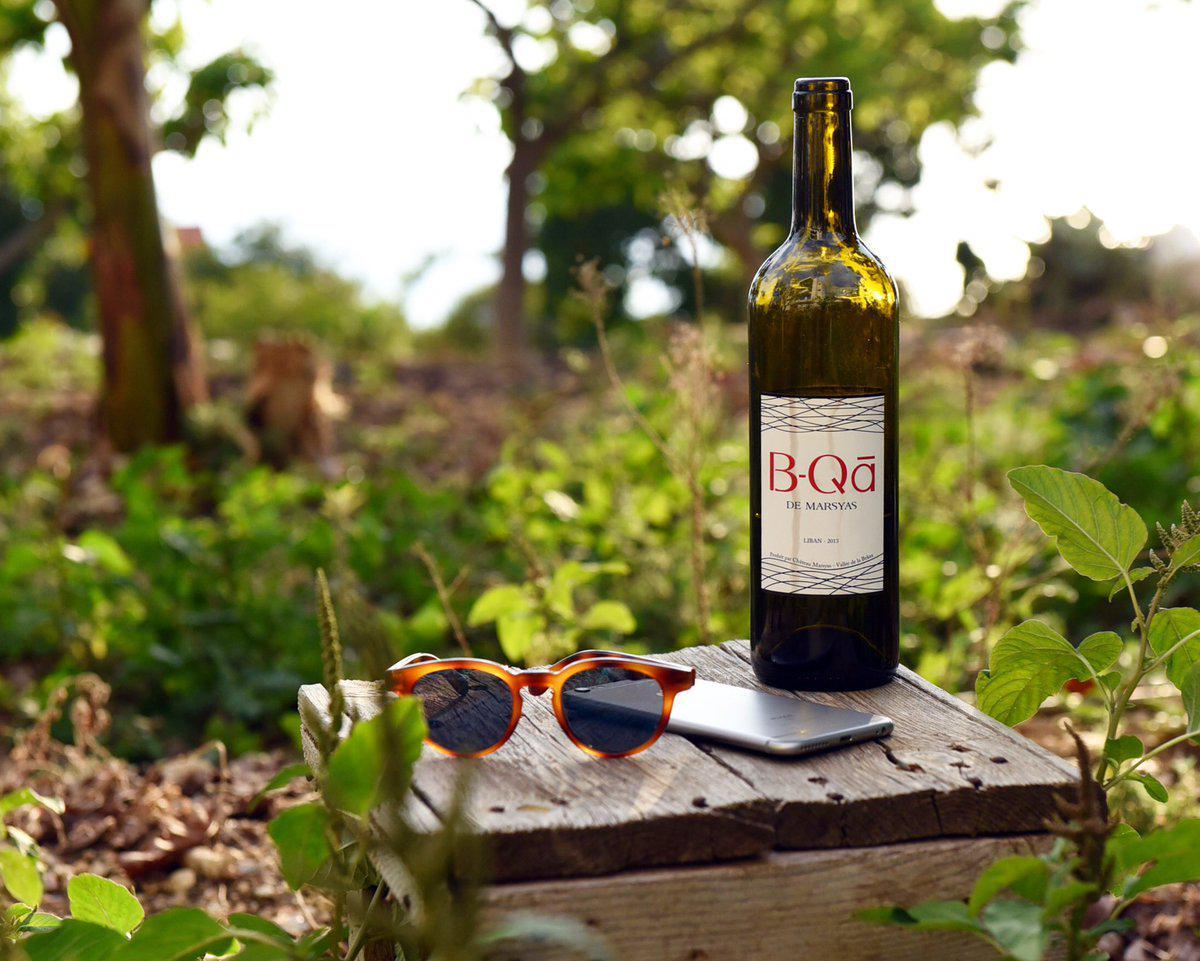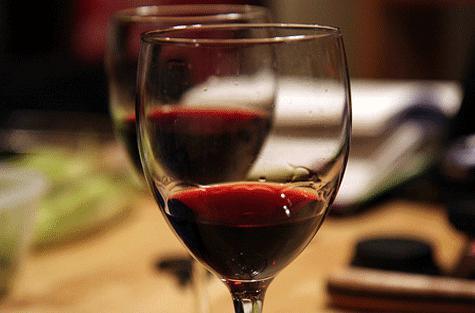The first image is the image on the left, the second image is the image on the right. Evaluate the accuracy of this statement regarding the images: "Wine is being poured in at least one image.". Is it true? Answer yes or no. No. The first image is the image on the left, the second image is the image on the right. Considering the images on both sides, is "There is a wine bottle in the iamge on the left" valid? Answer yes or no. Yes. 